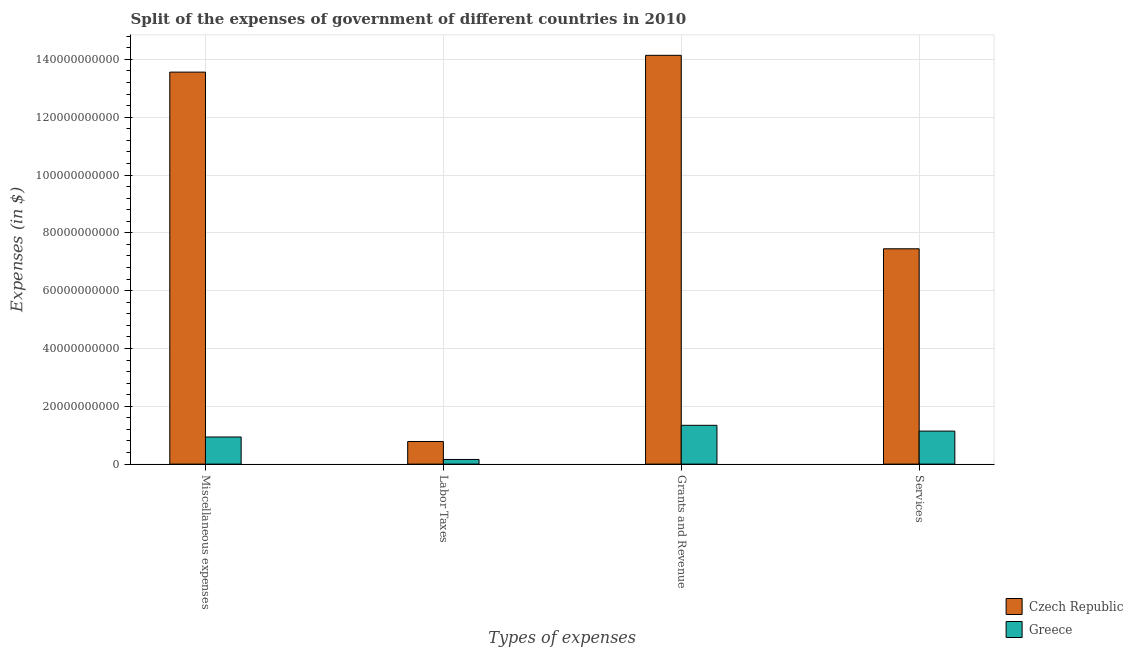How many groups of bars are there?
Keep it short and to the point. 4. Are the number of bars on each tick of the X-axis equal?
Keep it short and to the point. Yes. What is the label of the 1st group of bars from the left?
Ensure brevity in your answer.  Miscellaneous expenses. What is the amount spent on services in Czech Republic?
Provide a short and direct response. 7.45e+1. Across all countries, what is the maximum amount spent on grants and revenue?
Offer a terse response. 1.41e+11. Across all countries, what is the minimum amount spent on labor taxes?
Give a very brief answer. 1.61e+09. In which country was the amount spent on services maximum?
Make the answer very short. Czech Republic. What is the total amount spent on services in the graph?
Your answer should be compact. 8.59e+1. What is the difference between the amount spent on grants and revenue in Greece and that in Czech Republic?
Provide a short and direct response. -1.28e+11. What is the difference between the amount spent on miscellaneous expenses in Greece and the amount spent on services in Czech Republic?
Provide a succinct answer. -6.51e+1. What is the average amount spent on miscellaneous expenses per country?
Make the answer very short. 7.25e+1. What is the difference between the amount spent on grants and revenue and amount spent on labor taxes in Greece?
Provide a succinct answer. 1.18e+1. In how many countries, is the amount spent on services greater than 60000000000 $?
Your answer should be compact. 1. What is the ratio of the amount spent on miscellaneous expenses in Czech Republic to that in Greece?
Keep it short and to the point. 14.45. What is the difference between the highest and the second highest amount spent on services?
Provide a succinct answer. 6.31e+1. What is the difference between the highest and the lowest amount spent on miscellaneous expenses?
Offer a terse response. 1.26e+11. In how many countries, is the amount spent on miscellaneous expenses greater than the average amount spent on miscellaneous expenses taken over all countries?
Keep it short and to the point. 1. Is it the case that in every country, the sum of the amount spent on grants and revenue and amount spent on labor taxes is greater than the sum of amount spent on miscellaneous expenses and amount spent on services?
Offer a very short reply. No. What does the 2nd bar from the left in Services represents?
Offer a terse response. Greece. What does the 2nd bar from the right in Miscellaneous expenses represents?
Your response must be concise. Czech Republic. Is it the case that in every country, the sum of the amount spent on miscellaneous expenses and amount spent on labor taxes is greater than the amount spent on grants and revenue?
Ensure brevity in your answer.  No. How many bars are there?
Keep it short and to the point. 8. Are all the bars in the graph horizontal?
Give a very brief answer. No. Does the graph contain any zero values?
Offer a terse response. No. Where does the legend appear in the graph?
Keep it short and to the point. Bottom right. How many legend labels are there?
Provide a short and direct response. 2. What is the title of the graph?
Provide a succinct answer. Split of the expenses of government of different countries in 2010. What is the label or title of the X-axis?
Keep it short and to the point. Types of expenses. What is the label or title of the Y-axis?
Give a very brief answer. Expenses (in $). What is the Expenses (in $) in Czech Republic in Miscellaneous expenses?
Keep it short and to the point. 1.36e+11. What is the Expenses (in $) in Greece in Miscellaneous expenses?
Offer a very short reply. 9.38e+09. What is the Expenses (in $) of Czech Republic in Labor Taxes?
Make the answer very short. 7.82e+09. What is the Expenses (in $) in Greece in Labor Taxes?
Offer a very short reply. 1.61e+09. What is the Expenses (in $) in Czech Republic in Grants and Revenue?
Give a very brief answer. 1.41e+11. What is the Expenses (in $) of Greece in Grants and Revenue?
Your answer should be compact. 1.34e+1. What is the Expenses (in $) of Czech Republic in Services?
Ensure brevity in your answer.  7.45e+1. What is the Expenses (in $) of Greece in Services?
Ensure brevity in your answer.  1.14e+1. Across all Types of expenses, what is the maximum Expenses (in $) of Czech Republic?
Your answer should be very brief. 1.41e+11. Across all Types of expenses, what is the maximum Expenses (in $) in Greece?
Give a very brief answer. 1.34e+1. Across all Types of expenses, what is the minimum Expenses (in $) of Czech Republic?
Offer a very short reply. 7.82e+09. Across all Types of expenses, what is the minimum Expenses (in $) of Greece?
Provide a short and direct response. 1.61e+09. What is the total Expenses (in $) of Czech Republic in the graph?
Your answer should be compact. 3.59e+11. What is the total Expenses (in $) in Greece in the graph?
Offer a very short reply. 3.58e+1. What is the difference between the Expenses (in $) in Czech Republic in Miscellaneous expenses and that in Labor Taxes?
Offer a terse response. 1.28e+11. What is the difference between the Expenses (in $) of Greece in Miscellaneous expenses and that in Labor Taxes?
Give a very brief answer. 7.77e+09. What is the difference between the Expenses (in $) in Czech Republic in Miscellaneous expenses and that in Grants and Revenue?
Provide a succinct answer. -5.81e+09. What is the difference between the Expenses (in $) in Greece in Miscellaneous expenses and that in Grants and Revenue?
Ensure brevity in your answer.  -4.04e+09. What is the difference between the Expenses (in $) in Czech Republic in Miscellaneous expenses and that in Services?
Provide a short and direct response. 6.11e+1. What is the difference between the Expenses (in $) in Greece in Miscellaneous expenses and that in Services?
Offer a terse response. -2.04e+09. What is the difference between the Expenses (in $) of Czech Republic in Labor Taxes and that in Grants and Revenue?
Ensure brevity in your answer.  -1.34e+11. What is the difference between the Expenses (in $) in Greece in Labor Taxes and that in Grants and Revenue?
Give a very brief answer. -1.18e+1. What is the difference between the Expenses (in $) of Czech Republic in Labor Taxes and that in Services?
Your response must be concise. -6.67e+1. What is the difference between the Expenses (in $) of Greece in Labor Taxes and that in Services?
Your answer should be compact. -9.81e+09. What is the difference between the Expenses (in $) in Czech Republic in Grants and Revenue and that in Services?
Your answer should be compact. 6.69e+1. What is the difference between the Expenses (in $) of Greece in Grants and Revenue and that in Services?
Give a very brief answer. 2.00e+09. What is the difference between the Expenses (in $) of Czech Republic in Miscellaneous expenses and the Expenses (in $) of Greece in Labor Taxes?
Provide a short and direct response. 1.34e+11. What is the difference between the Expenses (in $) of Czech Republic in Miscellaneous expenses and the Expenses (in $) of Greece in Grants and Revenue?
Provide a short and direct response. 1.22e+11. What is the difference between the Expenses (in $) in Czech Republic in Miscellaneous expenses and the Expenses (in $) in Greece in Services?
Provide a short and direct response. 1.24e+11. What is the difference between the Expenses (in $) of Czech Republic in Labor Taxes and the Expenses (in $) of Greece in Grants and Revenue?
Keep it short and to the point. -5.60e+09. What is the difference between the Expenses (in $) of Czech Republic in Labor Taxes and the Expenses (in $) of Greece in Services?
Provide a succinct answer. -3.60e+09. What is the difference between the Expenses (in $) of Czech Republic in Grants and Revenue and the Expenses (in $) of Greece in Services?
Offer a very short reply. 1.30e+11. What is the average Expenses (in $) of Czech Republic per Types of expenses?
Provide a short and direct response. 8.98e+1. What is the average Expenses (in $) in Greece per Types of expenses?
Keep it short and to the point. 8.96e+09. What is the difference between the Expenses (in $) of Czech Republic and Expenses (in $) of Greece in Miscellaneous expenses?
Ensure brevity in your answer.  1.26e+11. What is the difference between the Expenses (in $) of Czech Republic and Expenses (in $) of Greece in Labor Taxes?
Keep it short and to the point. 6.21e+09. What is the difference between the Expenses (in $) in Czech Republic and Expenses (in $) in Greece in Grants and Revenue?
Ensure brevity in your answer.  1.28e+11. What is the difference between the Expenses (in $) in Czech Republic and Expenses (in $) in Greece in Services?
Keep it short and to the point. 6.31e+1. What is the ratio of the Expenses (in $) in Czech Republic in Miscellaneous expenses to that in Labor Taxes?
Your response must be concise. 17.33. What is the ratio of the Expenses (in $) of Greece in Miscellaneous expenses to that in Labor Taxes?
Ensure brevity in your answer.  5.82. What is the ratio of the Expenses (in $) in Czech Republic in Miscellaneous expenses to that in Grants and Revenue?
Offer a terse response. 0.96. What is the ratio of the Expenses (in $) of Greece in Miscellaneous expenses to that in Grants and Revenue?
Your response must be concise. 0.7. What is the ratio of the Expenses (in $) in Czech Republic in Miscellaneous expenses to that in Services?
Your response must be concise. 1.82. What is the ratio of the Expenses (in $) in Greece in Miscellaneous expenses to that in Services?
Offer a terse response. 0.82. What is the ratio of the Expenses (in $) in Czech Republic in Labor Taxes to that in Grants and Revenue?
Offer a terse response. 0.06. What is the ratio of the Expenses (in $) in Greece in Labor Taxes to that in Grants and Revenue?
Provide a short and direct response. 0.12. What is the ratio of the Expenses (in $) of Czech Republic in Labor Taxes to that in Services?
Offer a terse response. 0.11. What is the ratio of the Expenses (in $) in Greece in Labor Taxes to that in Services?
Make the answer very short. 0.14. What is the ratio of the Expenses (in $) in Czech Republic in Grants and Revenue to that in Services?
Make the answer very short. 1.9. What is the ratio of the Expenses (in $) in Greece in Grants and Revenue to that in Services?
Provide a short and direct response. 1.18. What is the difference between the highest and the second highest Expenses (in $) in Czech Republic?
Keep it short and to the point. 5.81e+09. What is the difference between the highest and the second highest Expenses (in $) in Greece?
Offer a very short reply. 2.00e+09. What is the difference between the highest and the lowest Expenses (in $) of Czech Republic?
Provide a short and direct response. 1.34e+11. What is the difference between the highest and the lowest Expenses (in $) in Greece?
Offer a terse response. 1.18e+1. 